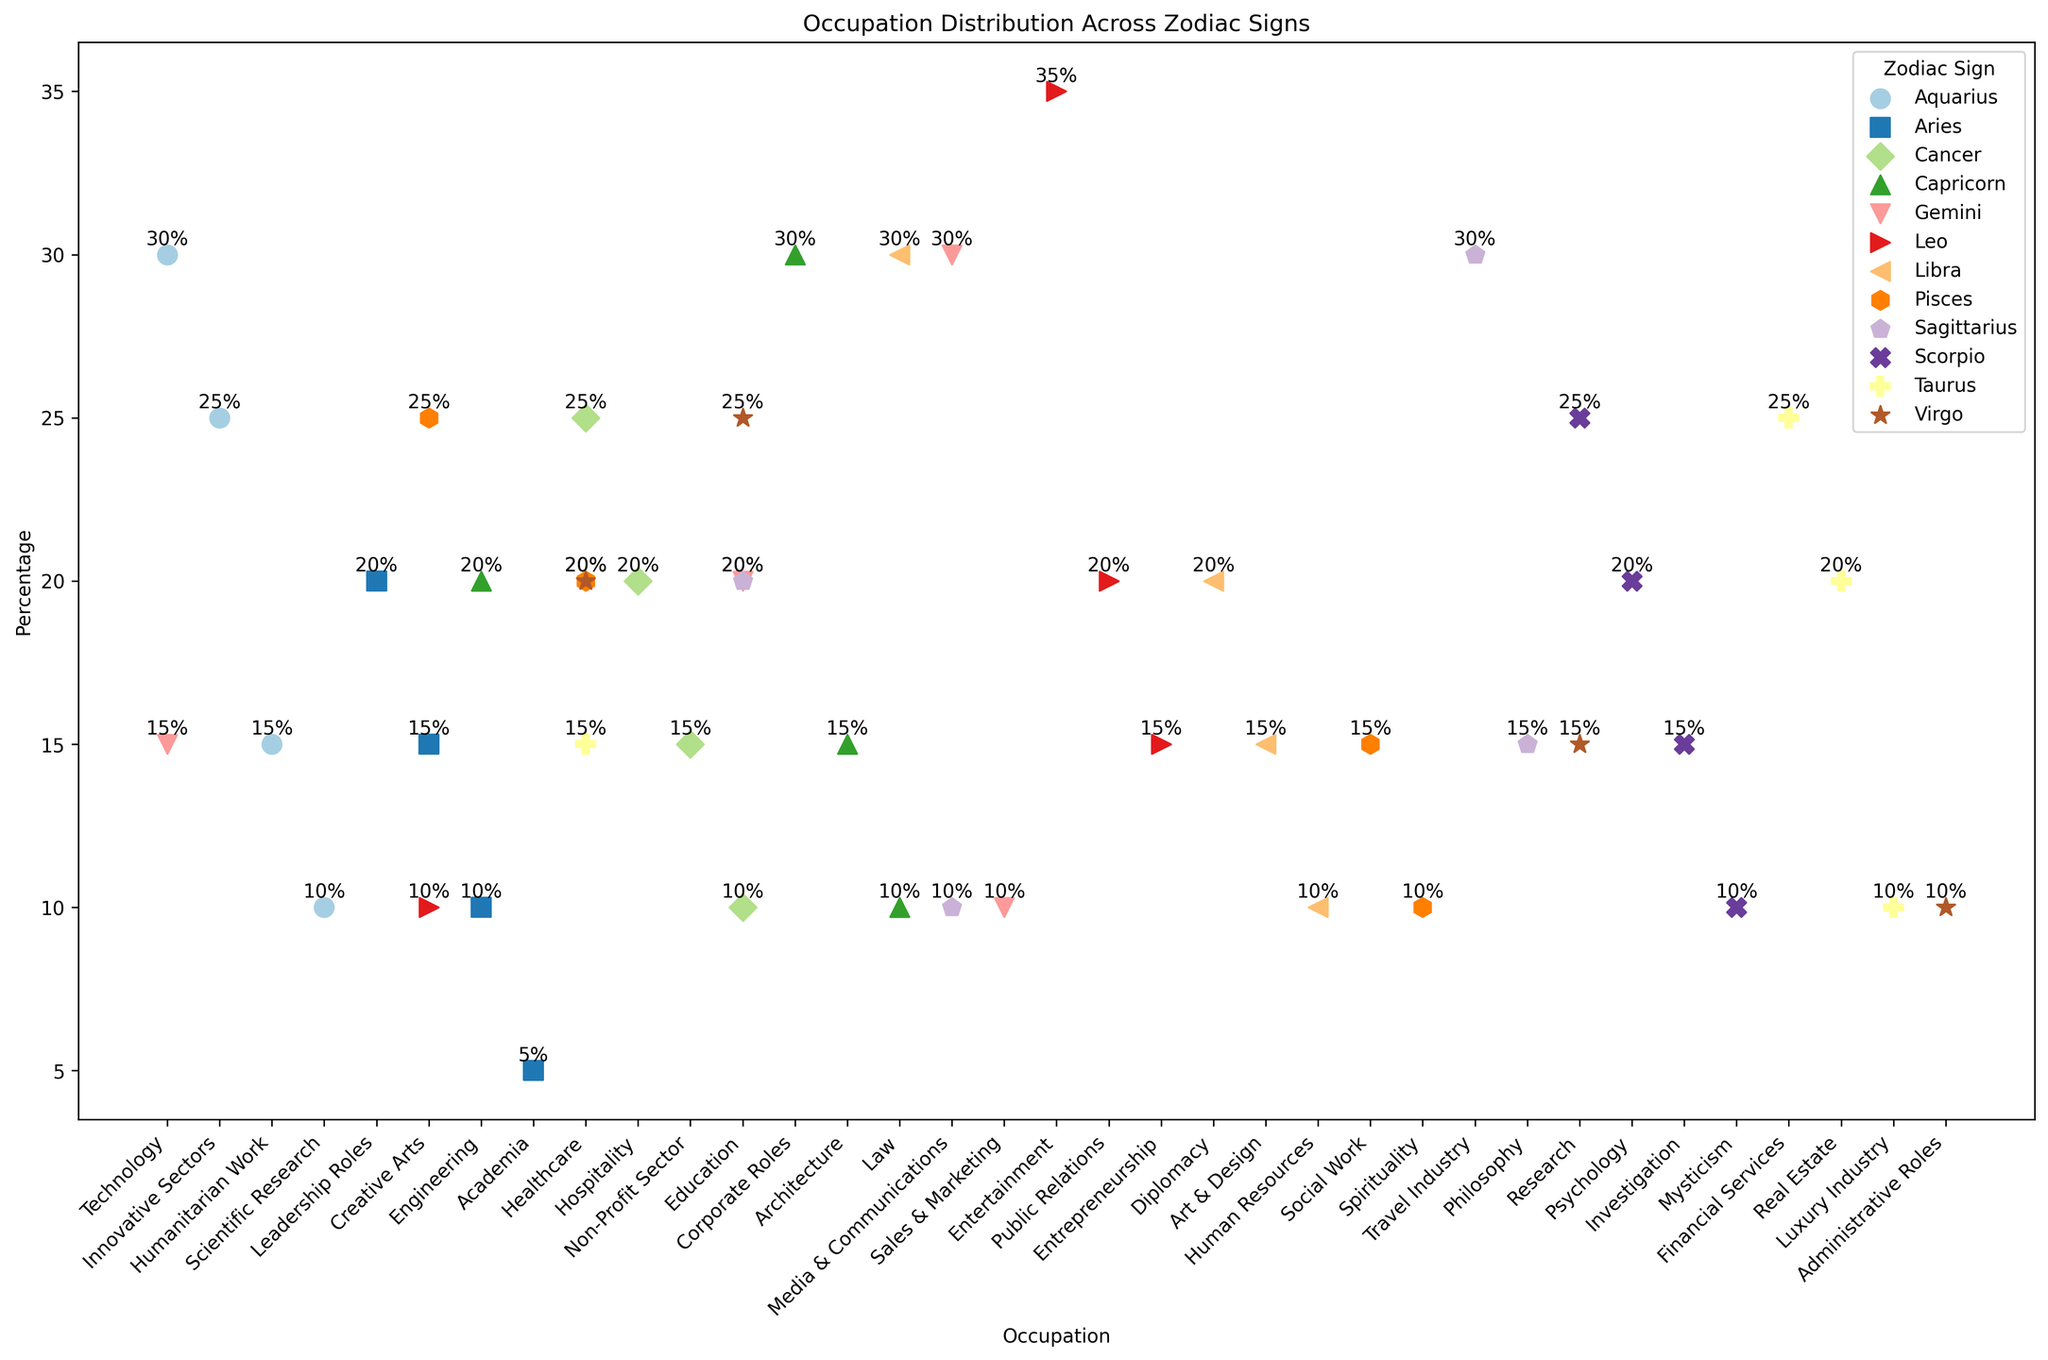Which zodiac sign has the highest percentage in the Healthcare occupation? Scan the Healthcare row and compare percentages for each zodiac sign. Cancer has the highest participation with 25%.
Answer: Cancer What is the combined percentage of Aries in Leadership Roles and Creative Arts? Add the percentages of Aries in Leadership Roles (20%) and Creative Arts (15%). 20% + 15% = 35%.
Answer: 35% Which occupation has the highest representation for Leo? Look at the percentages for each occupation under Leo. Entertainment has the highest percentage at 35%.
Answer: Entertainment How does the percentage of Gemini in Technology compare to that in Media & Communications? Compare the percentage of Gemini in Technology (15%) with that in Media & Communications (30%). Media & Communications is higher.
Answer: Media & Communications Which zodiac sign shows the most diverse occupation distribution? Determine the zodiac sign with the widest range of percentages across different occupations by comparing the maximum and minimum values of each zodiac sign. Pisces has a range from 10% to 25%, showing diversity in its occupations.
Answer: Pisces What is the average percentage of Virgo’s representation in all listed occupations? Add the percentages of Virgo’s occupations (25% + 20% + 15% + 10%) and divide by the number of occupations (4). (25% + 20% + 15% + 10%) / 4 = 17.5%.
Answer: 17.5% Between Scorpio and Sagittarius, which zodiac sign has a higher percentage in Research? Compare Scorpio's percentage in Research (25%) with Sagittarius's (which is not present). Therefore, Scorpio has the higher percentage.
Answer: Scorpio Which zodiac sign has the least representation in Academia? Look for the sign with the lowest value in Academia. Aries is the only sign with representation in Academia, at 5%.
Answer: Aries Compare the percentage of Capricorn in Corporate Roles to that of Libra in Law. Which is higher? Compare Capricorn in Corporate Roles (30%) with Libra in Law (30%). Both are equal in percentage.
Answer: Equal What is the total percentage of all occupations for Aquarius? Sum up the percentages of Aquarius’s occupations (30% + 25% + 15% + 10%). 30% + 25% + 15% + 10% = 80%.
Answer: 80% 